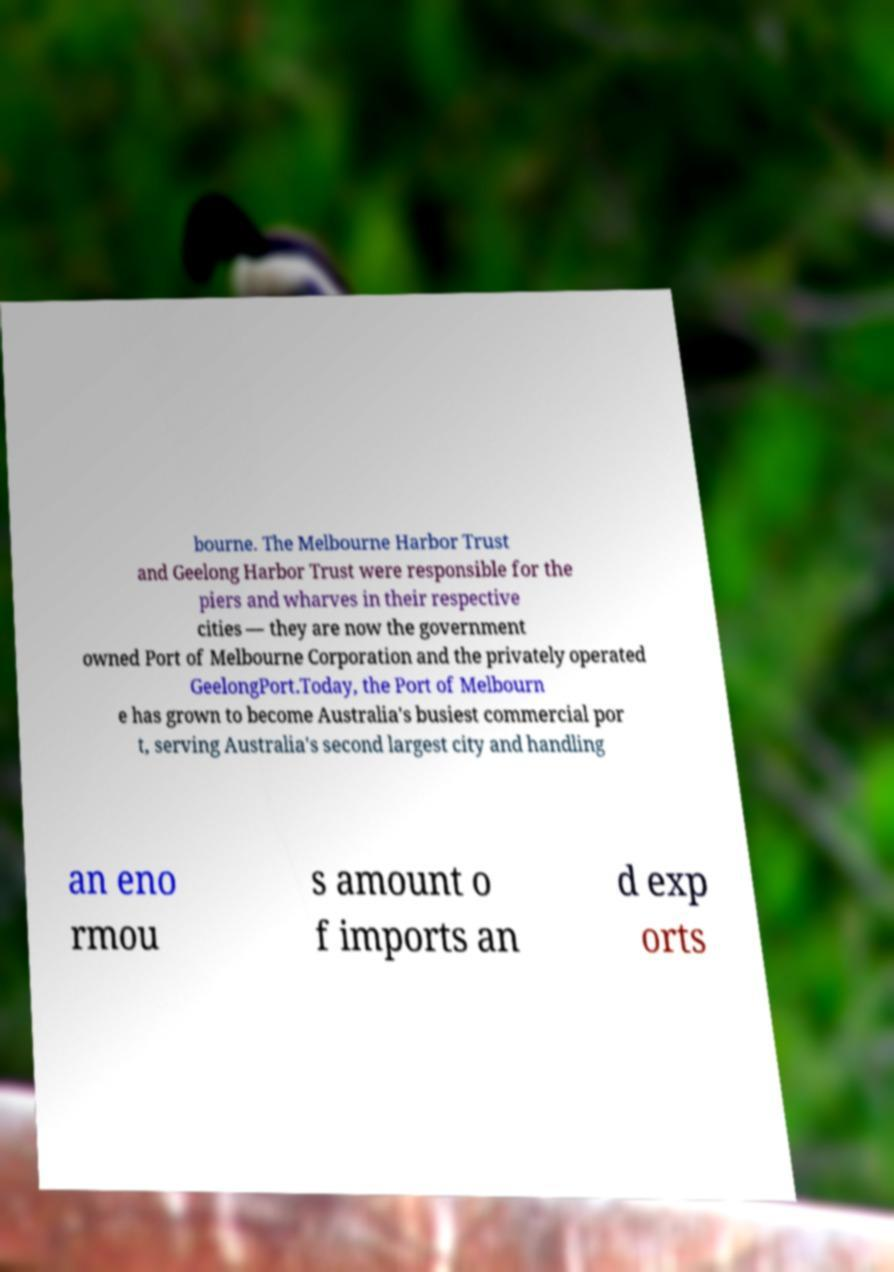Could you extract and type out the text from this image? bourne. The Melbourne Harbor Trust and Geelong Harbor Trust were responsible for the piers and wharves in their respective cities — they are now the government owned Port of Melbourne Corporation and the privately operated GeelongPort.Today, the Port of Melbourn e has grown to become Australia's busiest commercial por t, serving Australia's second largest city and handling an eno rmou s amount o f imports an d exp orts 